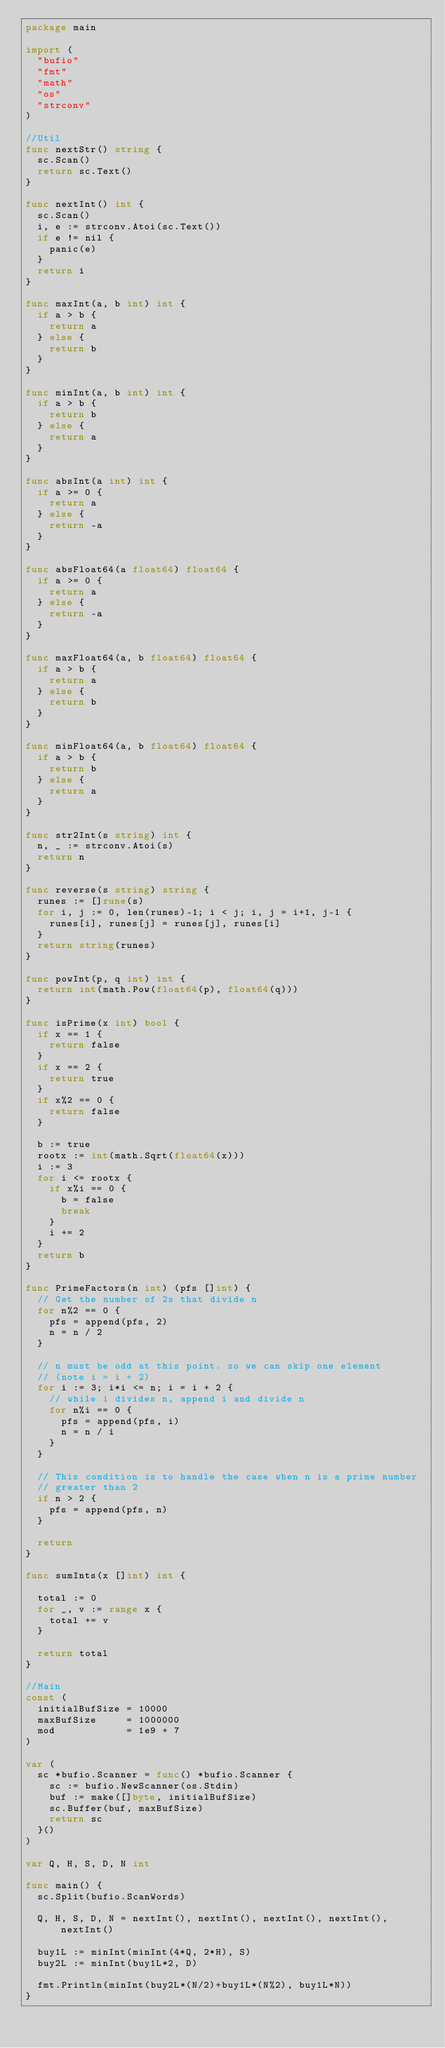<code> <loc_0><loc_0><loc_500><loc_500><_Go_>package main

import (
	"bufio"
	"fmt"
	"math"
	"os"
	"strconv"
)

//Util
func nextStr() string {
	sc.Scan()
	return sc.Text()
}

func nextInt() int {
	sc.Scan()
	i, e := strconv.Atoi(sc.Text())
	if e != nil {
		panic(e)
	}
	return i
}

func maxInt(a, b int) int {
	if a > b {
		return a
	} else {
		return b
	}
}

func minInt(a, b int) int {
	if a > b {
		return b
	} else {
		return a
	}
}

func absInt(a int) int {
	if a >= 0 {
		return a
	} else {
		return -a
	}
}

func absFloat64(a float64) float64 {
	if a >= 0 {
		return a
	} else {
		return -a
	}
}

func maxFloat64(a, b float64) float64 {
	if a > b {
		return a
	} else {
		return b
	}
}

func minFloat64(a, b float64) float64 {
	if a > b {
		return b
	} else {
		return a
	}
}

func str2Int(s string) int {
	n, _ := strconv.Atoi(s)
	return n
}

func reverse(s string) string {
	runes := []rune(s)
	for i, j := 0, len(runes)-1; i < j; i, j = i+1, j-1 {
		runes[i], runes[j] = runes[j], runes[i]
	}
	return string(runes)
}

func powInt(p, q int) int {
	return int(math.Pow(float64(p), float64(q)))
}

func isPrime(x int) bool {
	if x == 1 {
		return false
	}
	if x == 2 {
		return true
	}
	if x%2 == 0 {
		return false
	}

	b := true
	rootx := int(math.Sqrt(float64(x)))
	i := 3
	for i <= rootx {
		if x%i == 0 {
			b = false
			break
		}
		i += 2
	}
	return b
}

func PrimeFactors(n int) (pfs []int) {
	// Get the number of 2s that divide n
	for n%2 == 0 {
		pfs = append(pfs, 2)
		n = n / 2
	}

	// n must be odd at this point. so we can skip one element
	// (note i = i + 2)
	for i := 3; i*i <= n; i = i + 2 {
		// while i divides n, append i and divide n
		for n%i == 0 {
			pfs = append(pfs, i)
			n = n / i
		}
	}

	// This condition is to handle the case when n is a prime number
	// greater than 2
	if n > 2 {
		pfs = append(pfs, n)
	}

	return
}

func sumInts(x []int) int {

	total := 0
	for _, v := range x {
		total += v
	}

	return total
}

//Main
const (
	initialBufSize = 10000
	maxBufSize     = 1000000
	mod            = 1e9 + 7
)

var (
	sc *bufio.Scanner = func() *bufio.Scanner {
		sc := bufio.NewScanner(os.Stdin)
		buf := make([]byte, initialBufSize)
		sc.Buffer(buf, maxBufSize)
		return sc
	}()
)

var Q, H, S, D, N int

func main() {
	sc.Split(bufio.ScanWords)

	Q, H, S, D, N = nextInt(), nextInt(), nextInt(), nextInt(), nextInt()

	buy1L := minInt(minInt(4*Q, 2*H), S)
	buy2L := minInt(buy1L*2, D)

	fmt.Println(minInt(buy2L*(N/2)+buy1L*(N%2), buy1L*N))
}
</code> 